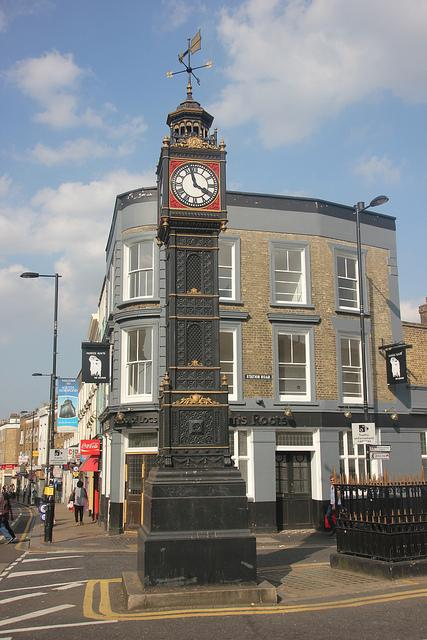This street is located where? england 